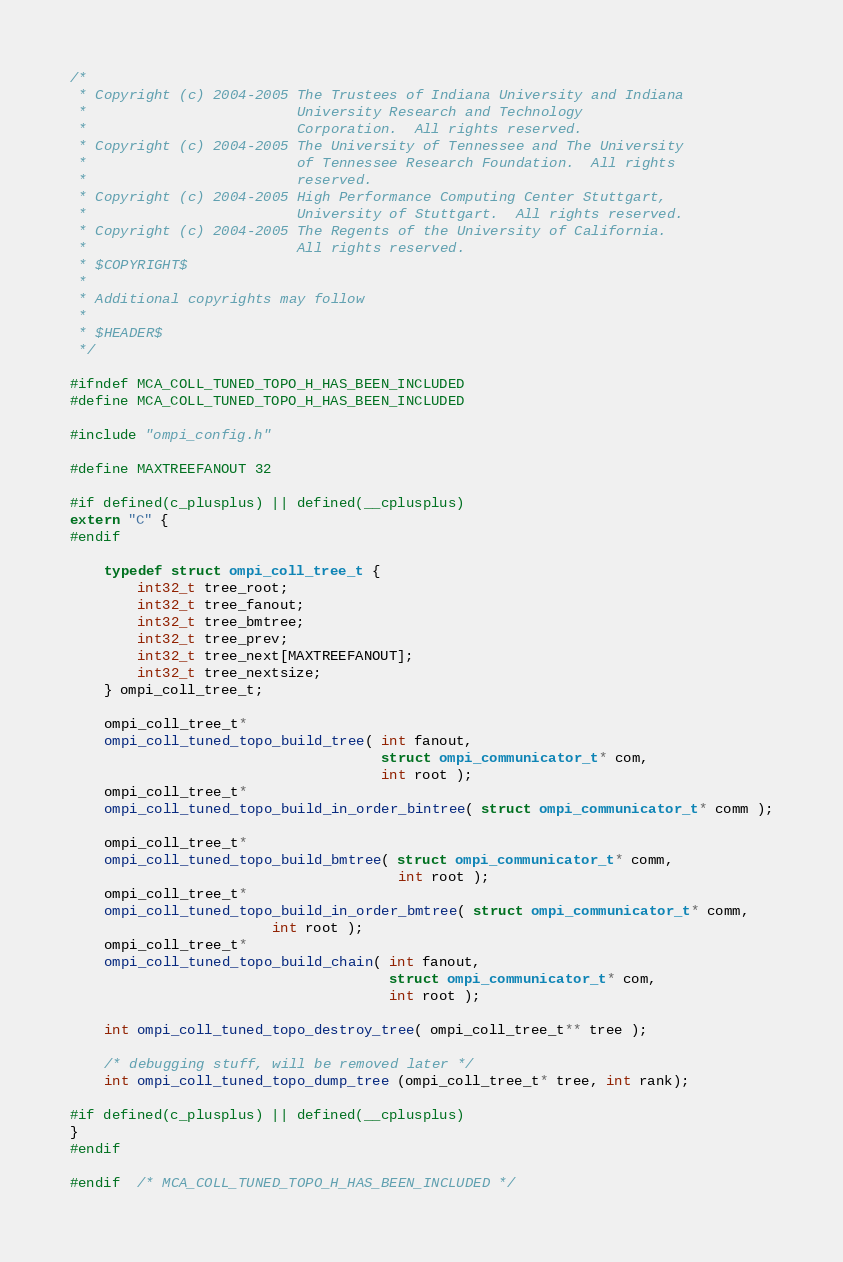Convert code to text. <code><loc_0><loc_0><loc_500><loc_500><_C_>/*
 * Copyright (c) 2004-2005 The Trustees of Indiana University and Indiana
 *                         University Research and Technology
 *                         Corporation.  All rights reserved.
 * Copyright (c) 2004-2005 The University of Tennessee and The University
 *                         of Tennessee Research Foundation.  All rights
 *                         reserved.
 * Copyright (c) 2004-2005 High Performance Computing Center Stuttgart, 
 *                         University of Stuttgart.  All rights reserved.
 * Copyright (c) 2004-2005 The Regents of the University of California.
 *                         All rights reserved.
 * $COPYRIGHT$
 * 
 * Additional copyrights may follow
 * 
 * $HEADER$
 */

#ifndef MCA_COLL_TUNED_TOPO_H_HAS_BEEN_INCLUDED
#define MCA_COLL_TUNED_TOPO_H_HAS_BEEN_INCLUDED

#include "ompi_config.h"

#define MAXTREEFANOUT 32

#if defined(c_plusplus) || defined(__cplusplus)
extern "C" {
#endif

    typedef struct ompi_coll_tree_t {
        int32_t tree_root;
        int32_t tree_fanout;
        int32_t tree_bmtree;
        int32_t tree_prev;
        int32_t tree_next[MAXTREEFANOUT];
        int32_t tree_nextsize;
    } ompi_coll_tree_t;

    ompi_coll_tree_t*
    ompi_coll_tuned_topo_build_tree( int fanout,
                                     struct ompi_communicator_t* com,
                                     int root );
    ompi_coll_tree_t*
    ompi_coll_tuned_topo_build_in_order_bintree( struct ompi_communicator_t* comm );

    ompi_coll_tree_t*
    ompi_coll_tuned_topo_build_bmtree( struct ompi_communicator_t* comm,
                                       int root );
    ompi_coll_tree_t*
    ompi_coll_tuned_topo_build_in_order_bmtree( struct ompi_communicator_t* comm,
						int root );
    ompi_coll_tree_t*
    ompi_coll_tuned_topo_build_chain( int fanout,
                                      struct ompi_communicator_t* com,
                                      int root );

    int ompi_coll_tuned_topo_destroy_tree( ompi_coll_tree_t** tree );

    /* debugging stuff, will be removed later */
    int ompi_coll_tuned_topo_dump_tree (ompi_coll_tree_t* tree, int rank);

#if defined(c_plusplus) || defined(__cplusplus)
}
#endif

#endif  /* MCA_COLL_TUNED_TOPO_H_HAS_BEEN_INCLUDED */

</code> 